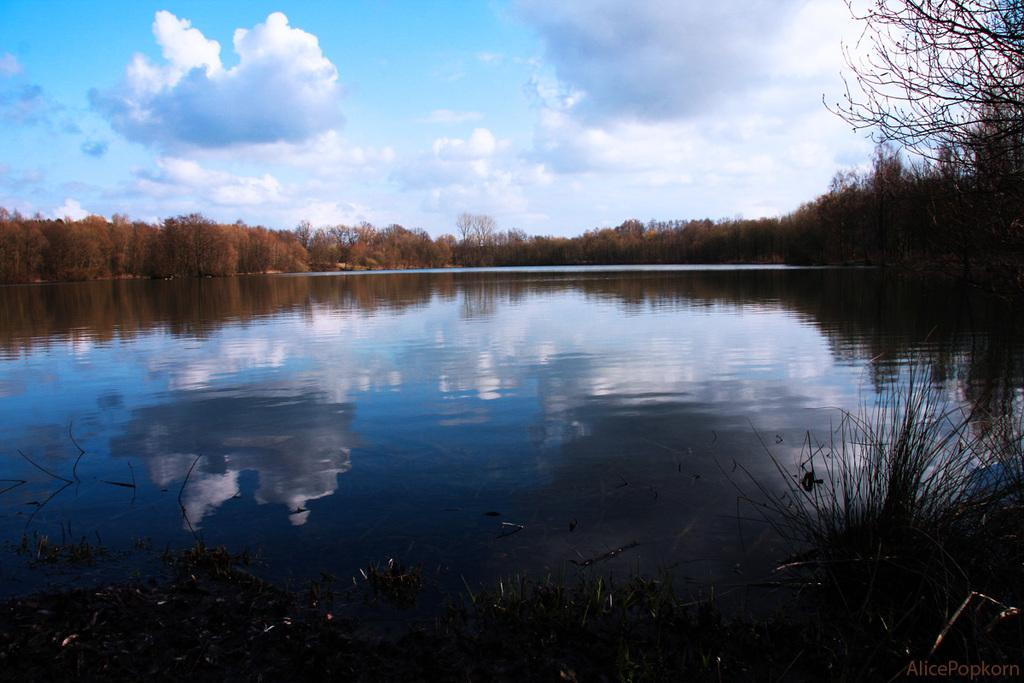What is the main subject in the center of the image? There is water in the center of the image. What can be seen in the background of the image? There are trees in the background of the image. How would you describe the sky in the image? The sky is cloudy in the image. What type of locket is hanging from the tree in the image? There is no locket present in the image; it only features water, trees, and a cloudy sky. 